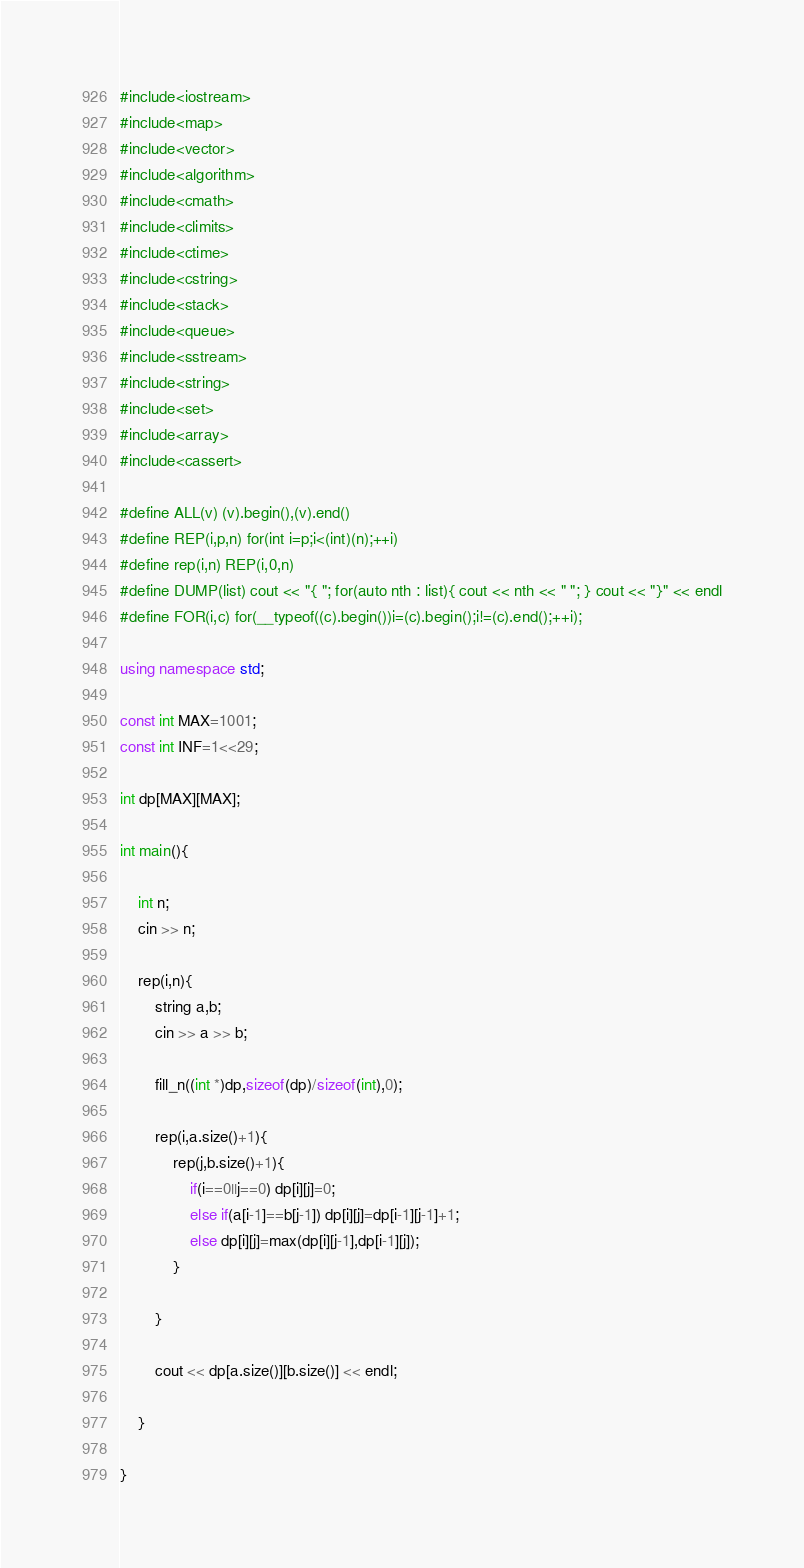Convert code to text. <code><loc_0><loc_0><loc_500><loc_500><_C++_>#include<iostream>
#include<map>
#include<vector>
#include<algorithm>
#include<cmath>
#include<climits>
#include<ctime>
#include<cstring>
#include<stack>
#include<queue>
#include<sstream>
#include<string>
#include<set>
#include<array>
#include<cassert>

#define ALL(v) (v).begin(),(v).end()
#define REP(i,p,n) for(int i=p;i<(int)(n);++i)
#define rep(i,n) REP(i,0,n)
#define DUMP(list) cout << "{ "; for(auto nth : list){ cout << nth << " "; } cout << "}" << endl
#define FOR(i,c) for(__typeof((c).begin())i=(c).begin();i!=(c).end();++i);

using namespace std;

const int MAX=1001;
const int INF=1<<29;

int dp[MAX][MAX];

int main(){

	int n;
	cin >> n;

	rep(i,n){
		string a,b;
		cin >> a >> b;
	
		fill_n((int *)dp,sizeof(dp)/sizeof(int),0);
		
		rep(i,a.size()+1){
			rep(j,b.size()+1){
				if(i==0||j==0) dp[i][j]=0;
				else if(a[i-1]==b[j-1]) dp[i][j]=dp[i-1][j-1]+1;
				else dp[i][j]=max(dp[i][j-1],dp[i-1][j]);
			}
		
		}

		cout << dp[a.size()][b.size()] << endl;
	
	}

}</code> 